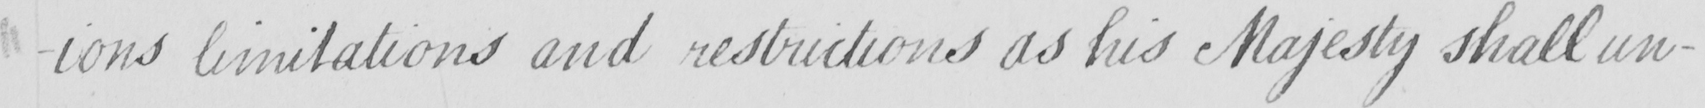Can you tell me what this handwritten text says? -ions limitations and restrictions as his Majesty shall un- 